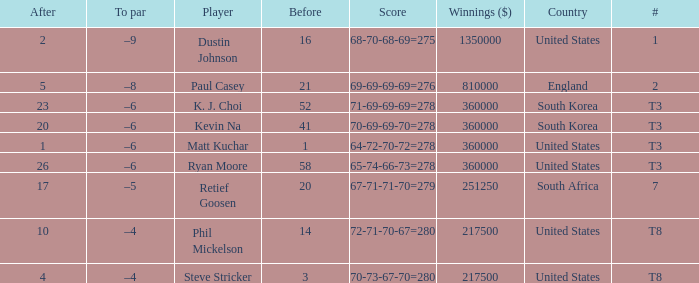What is the # listed when the score is 70-69-69-70=278? T3. 